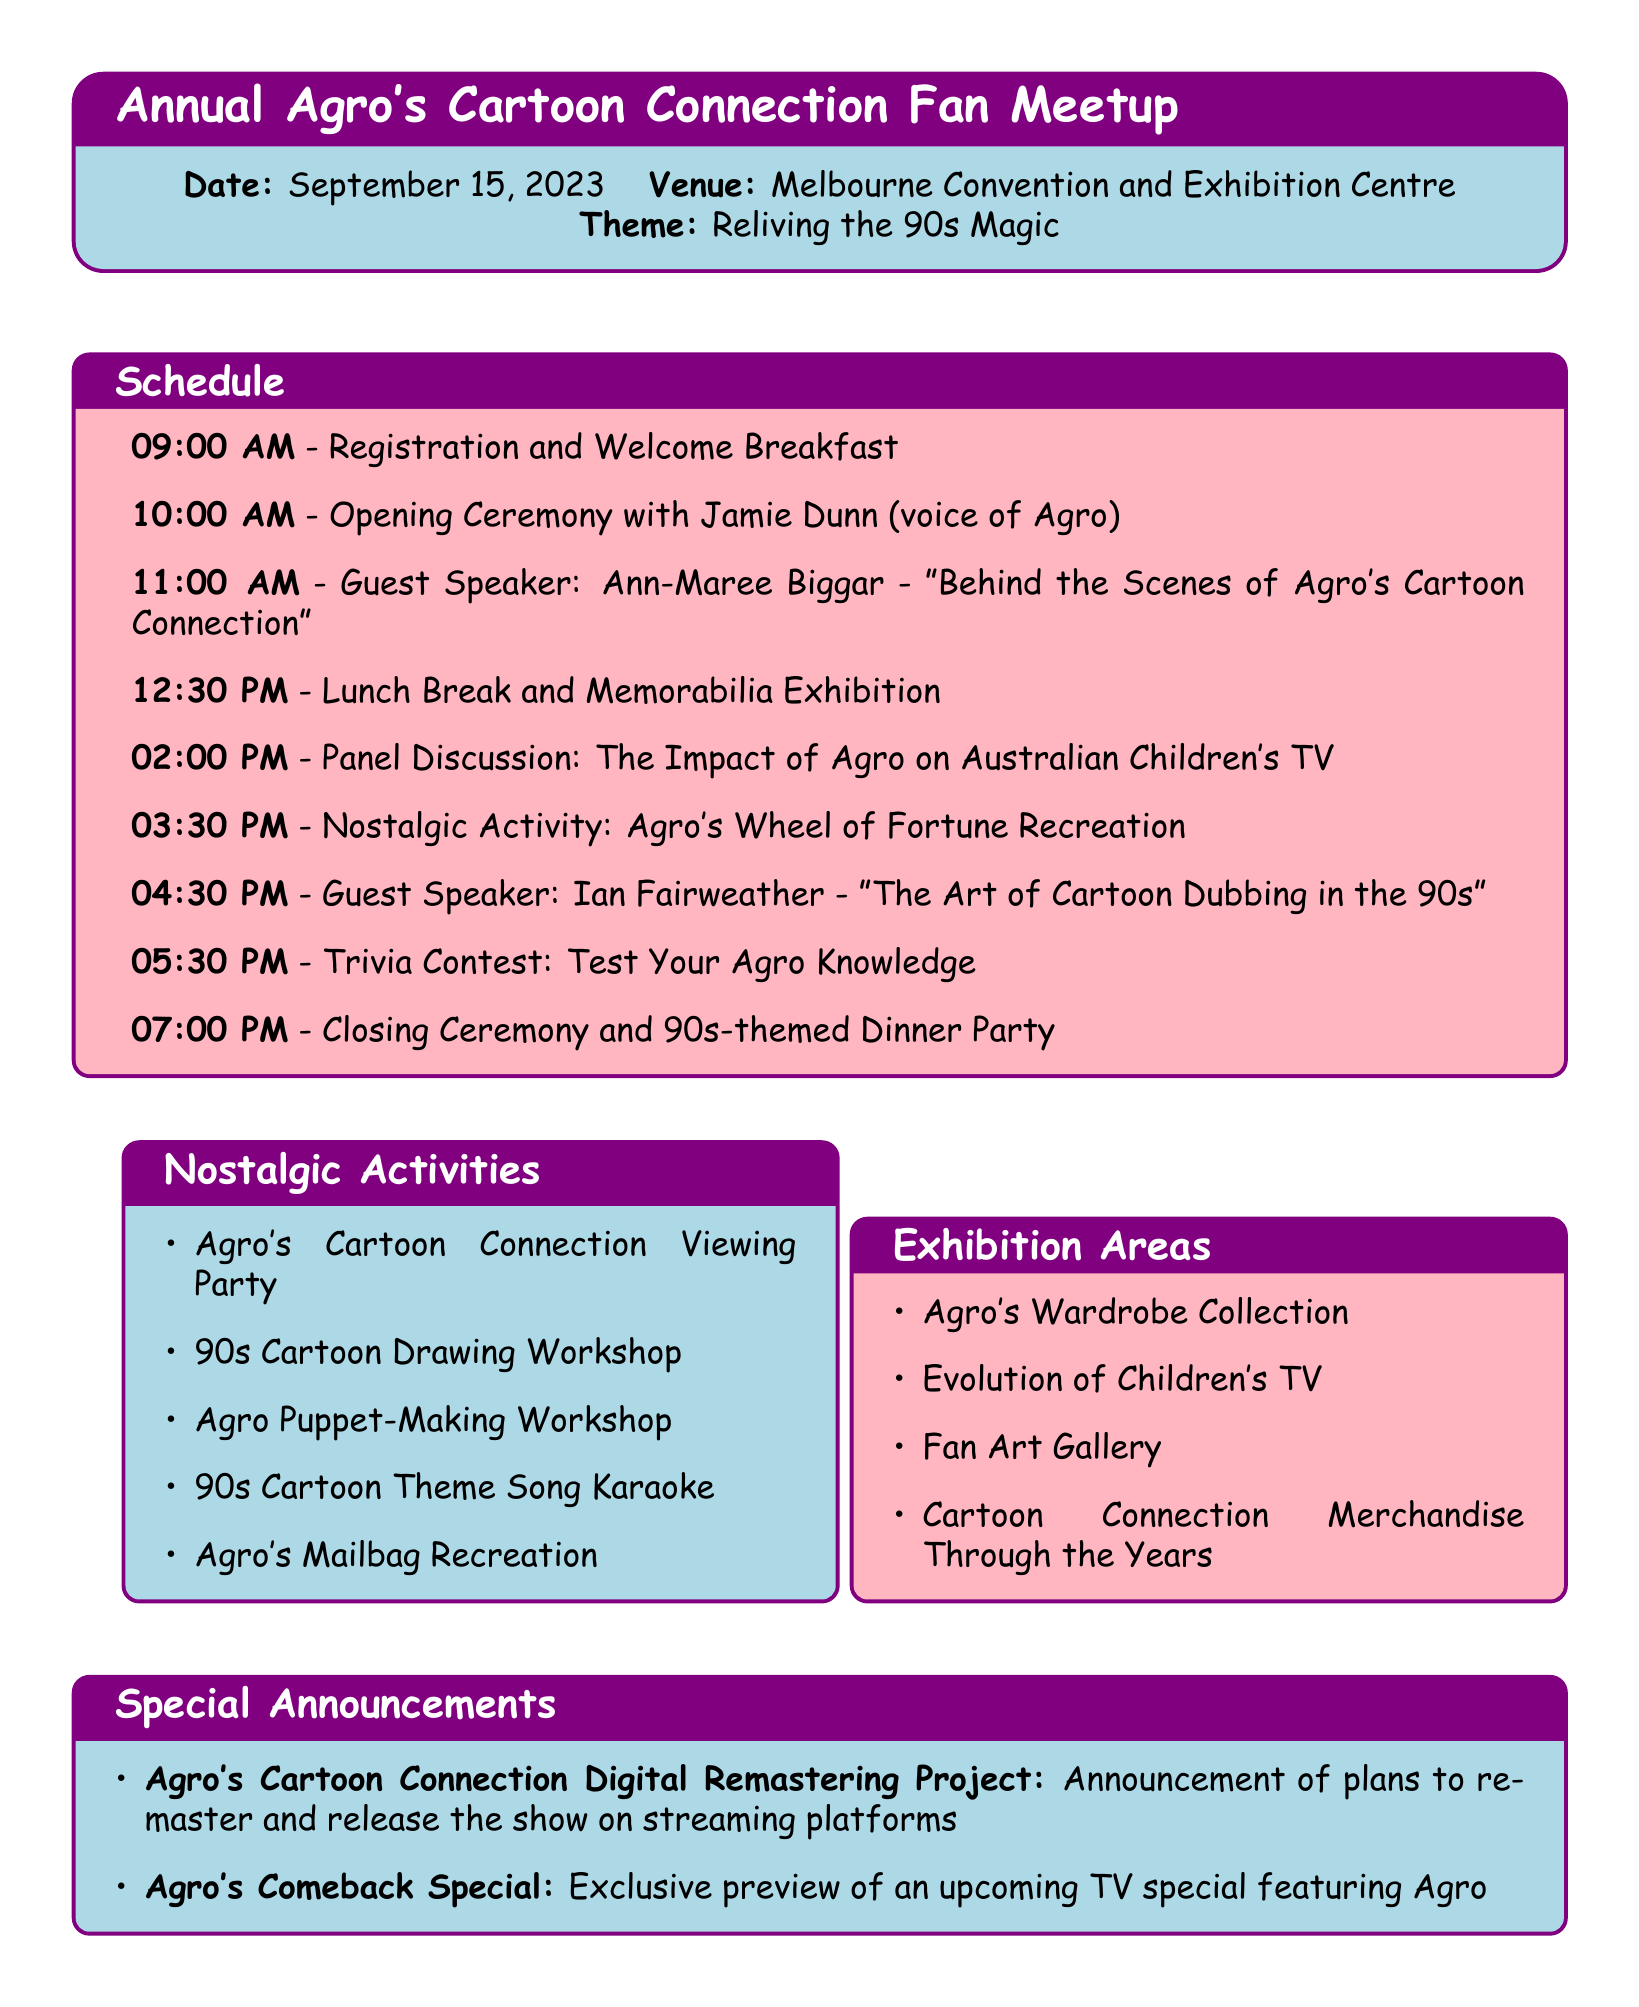What is the date of the meetup? The date of the meetup is specified in the event_details section of the document as September 15, 2023.
Answer: September 15, 2023 Who is the guest speaker at 11:00 AM? The guest speaker at 11:00 AM is listed in the schedule under the activity "Guest Speaker: Ann-Maree Biggar."
Answer: Ann-Maree Biggar What is the theme of the event? The theme of the event is noted in the event_details section as "Reliving the 90s Magic."
Answer: Reliving the 90s Magic Which activity takes place at 03:30 PM? The activity at 03:30 PM is mentioned in the schedule as "Nostalgic Activity: Agro's Wheel of Fortune Recreation."
Answer: Agro's Wheel of Fortune Recreation Name one of the exhibition areas. The document lists multiple exhibition areas, one of which is "Agro's Wardrobe Collection."
Answer: Agro's Wardrobe Collection What is the time for the closing ceremony? The closing ceremony time is detailed in the schedule as 07:00 PM.
Answer: 07:00 PM How many nostalgic activities are mentioned? The document includes five nostalgic activities listed under nostalgic_activities.
Answer: Five What is the title of the special announcement regarding remastering? The title is provided under special_announcements as "Agro's Cartoon Connection Digital Remastering Project."
Answer: Agro's Cartoon Connection Digital Remastering Project Who will be part of the panel discussion? The panelists are Terasa Livingstone, Daryl Somers, and Jane Smith as listed in the panel discussion section.
Answer: Terasa Livingstone, Daryl Somers, Jane Smith 